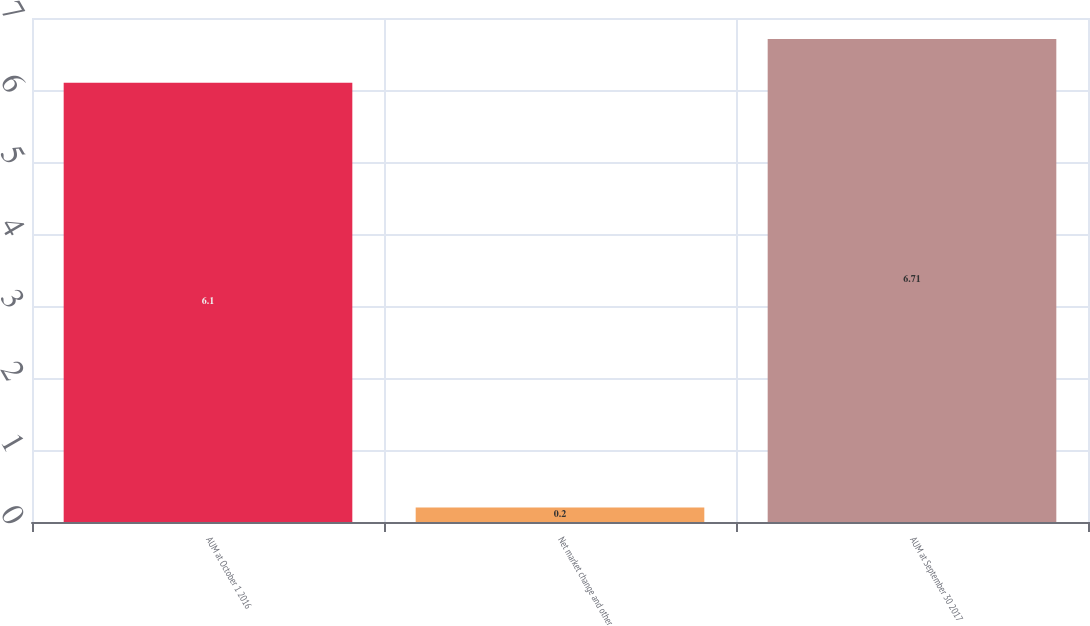Convert chart. <chart><loc_0><loc_0><loc_500><loc_500><bar_chart><fcel>AUM at October 1 2016<fcel>Net market change and other<fcel>AUM at September 30 2017<nl><fcel>6.1<fcel>0.2<fcel>6.71<nl></chart> 